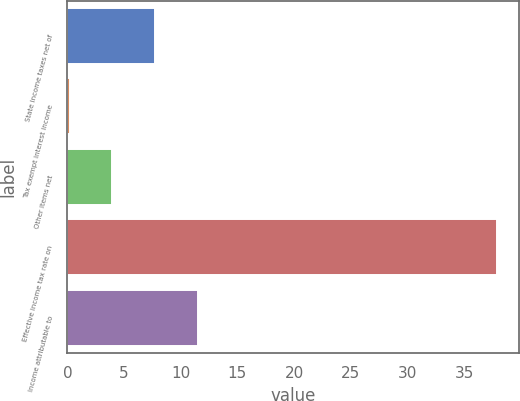Convert chart. <chart><loc_0><loc_0><loc_500><loc_500><bar_chart><fcel>State income taxes net of<fcel>Tax exempt interest income<fcel>Other items net<fcel>Effective income tax rate on<fcel>Income attributable to<nl><fcel>7.74<fcel>0.2<fcel>3.97<fcel>37.9<fcel>11.51<nl></chart> 